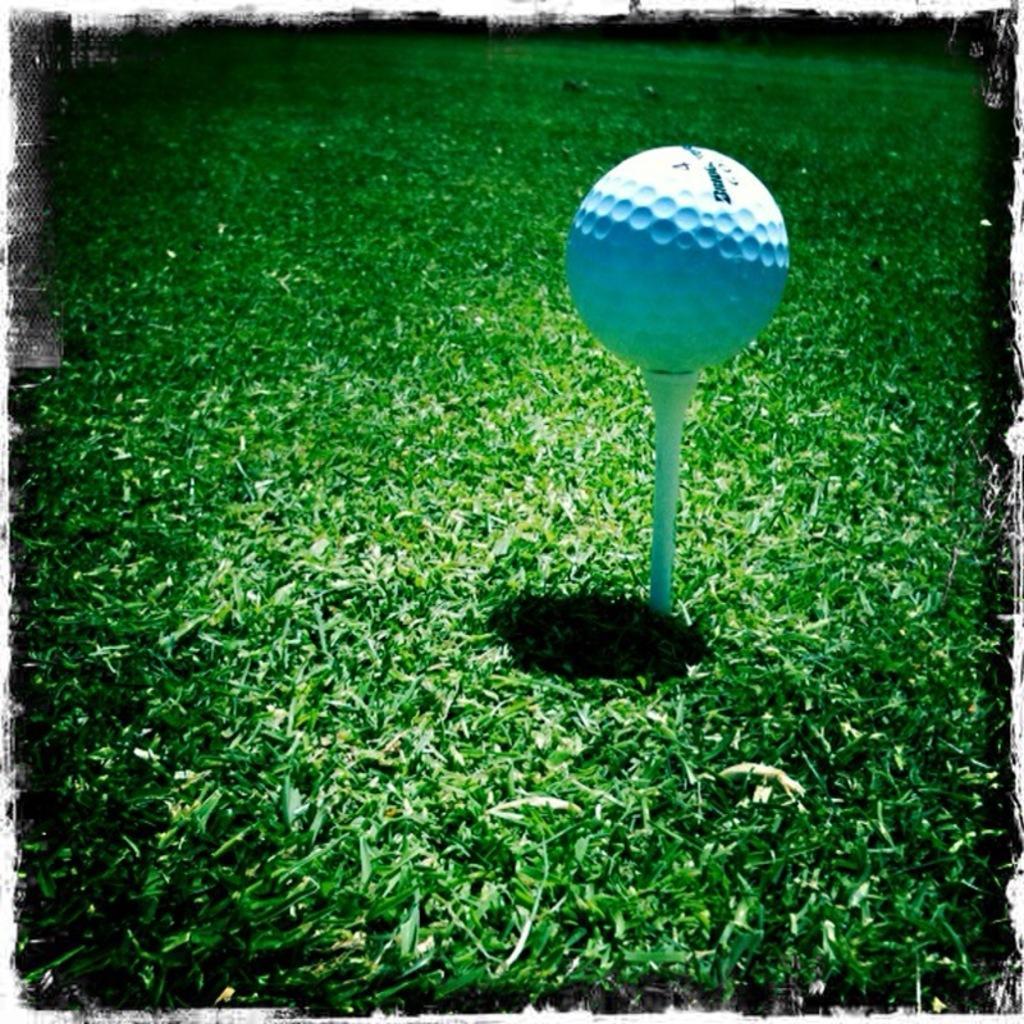Describe this image in one or two sentences. This picture contains a golf ball in white color is placed in the garden. In the background, we see the grass and it is green in color. 